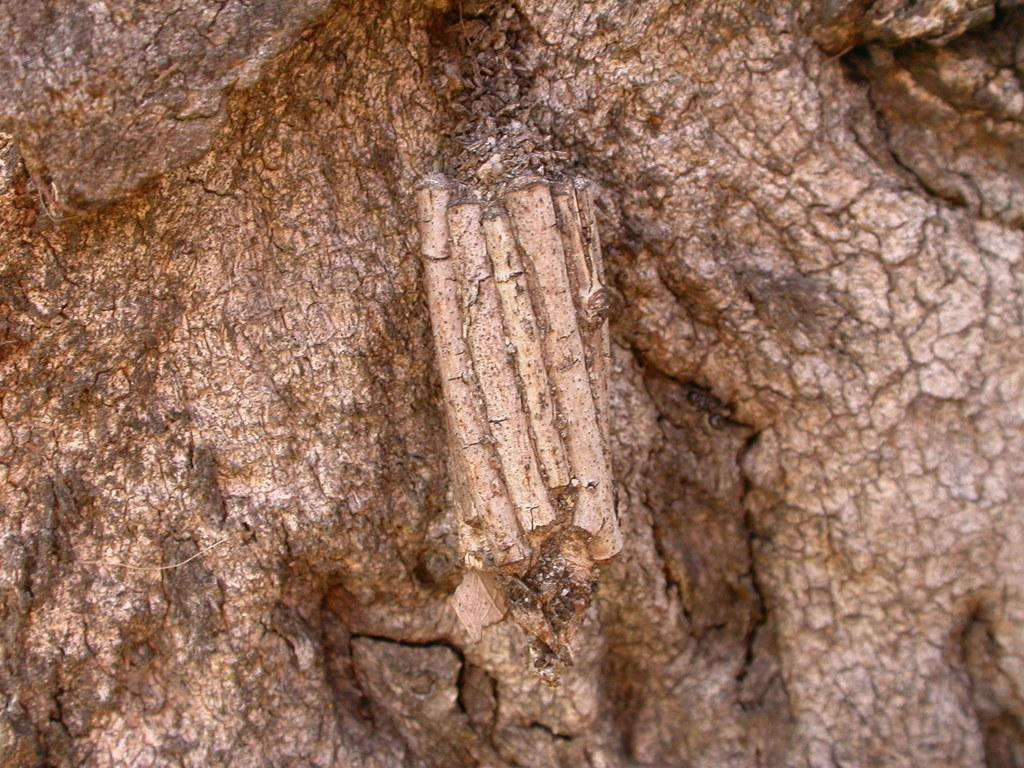What material is present in the image? There is wood in the image. How many rats are sitting on the wood in the image? There are no rats present in the image; it only features wood. What type of comfort can be found on the wood in the image? The image does not depict any type of comfort, as it only shows wood. 